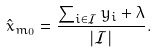<formula> <loc_0><loc_0><loc_500><loc_500>\hat { x } _ { m _ { 0 } } = \frac { \sum _ { i \in \mathcal { I } } y _ { i } + \lambda } { | \mathcal { I } | } .</formula> 